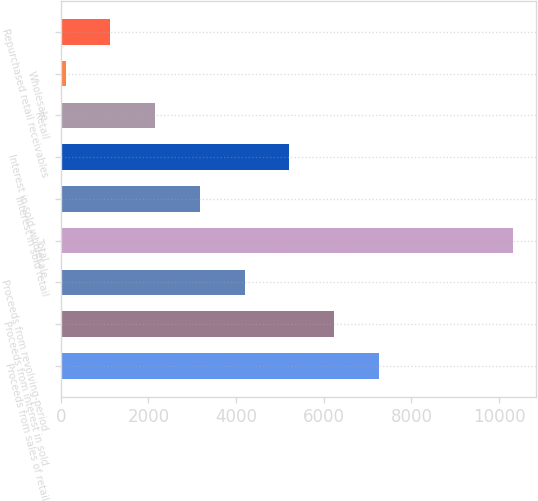Convert chart to OTSL. <chart><loc_0><loc_0><loc_500><loc_500><bar_chart><fcel>Proceeds from sales of retail<fcel>Proceeds from interest in sold<fcel>Proceeds from revolving-period<fcel>Total<fcel>Interest in sold retail<fcel>Interest in sold wholesale<fcel>Retail<fcel>Wholesale<fcel>Repurchased retail receivables<nl><fcel>7256.9<fcel>6236.2<fcel>4194.8<fcel>10319<fcel>3174.1<fcel>5215.5<fcel>2153.4<fcel>112<fcel>1132.7<nl></chart> 